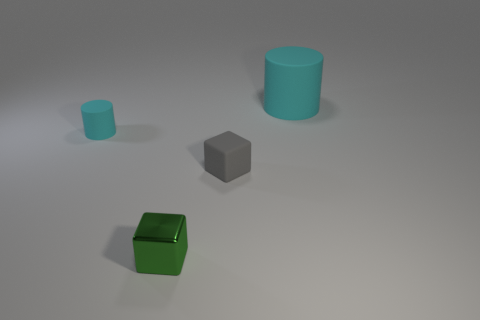Add 4 small things. How many objects exist? 8 Subtract 0 yellow balls. How many objects are left? 4 Subtract all large purple metallic things. Subtract all big cyan cylinders. How many objects are left? 3 Add 3 green metal blocks. How many green metal blocks are left? 4 Add 4 cubes. How many cubes exist? 6 